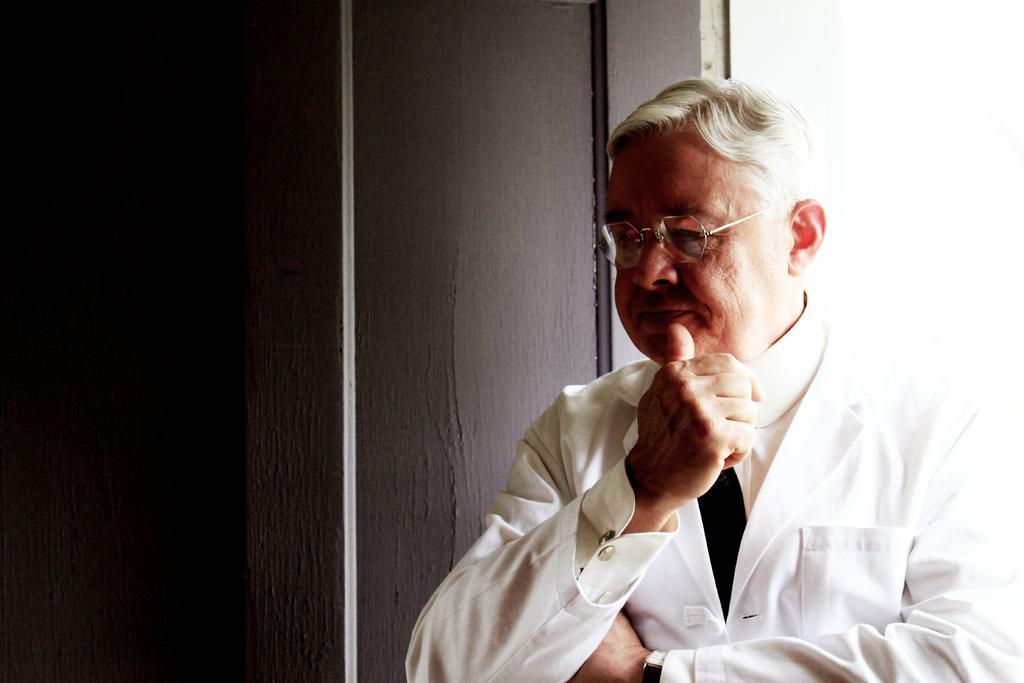Can you describe this image briefly? In the image there is a man, he is standing beside a wall. 